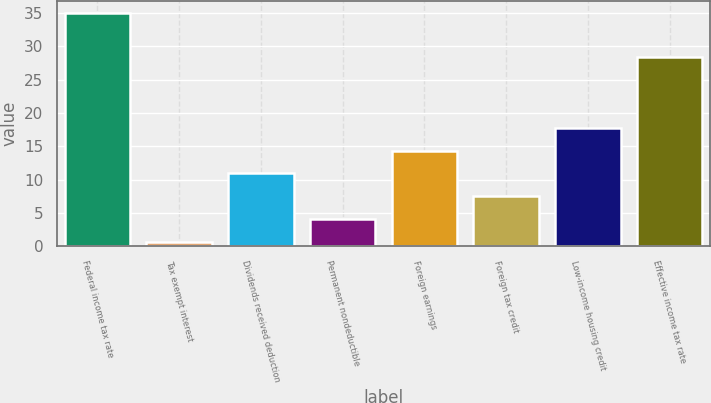Convert chart. <chart><loc_0><loc_0><loc_500><loc_500><bar_chart><fcel>Federal income tax rate<fcel>Tax exempt interest<fcel>Dividends received deduction<fcel>Permanent nondeductible<fcel>Foreign earnings<fcel>Foreign tax credit<fcel>Low-income housing credit<fcel>Effective income tax rate<nl><fcel>35<fcel>0.6<fcel>10.92<fcel>4.04<fcel>14.36<fcel>7.48<fcel>17.8<fcel>28.4<nl></chart> 